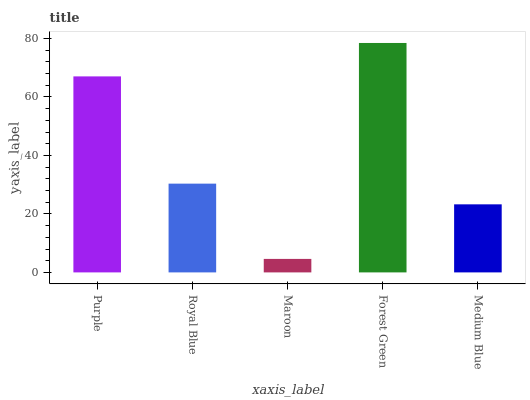Is Maroon the minimum?
Answer yes or no. Yes. Is Forest Green the maximum?
Answer yes or no. Yes. Is Royal Blue the minimum?
Answer yes or no. No. Is Royal Blue the maximum?
Answer yes or no. No. Is Purple greater than Royal Blue?
Answer yes or no. Yes. Is Royal Blue less than Purple?
Answer yes or no. Yes. Is Royal Blue greater than Purple?
Answer yes or no. No. Is Purple less than Royal Blue?
Answer yes or no. No. Is Royal Blue the high median?
Answer yes or no. Yes. Is Royal Blue the low median?
Answer yes or no. Yes. Is Purple the high median?
Answer yes or no. No. Is Purple the low median?
Answer yes or no. No. 